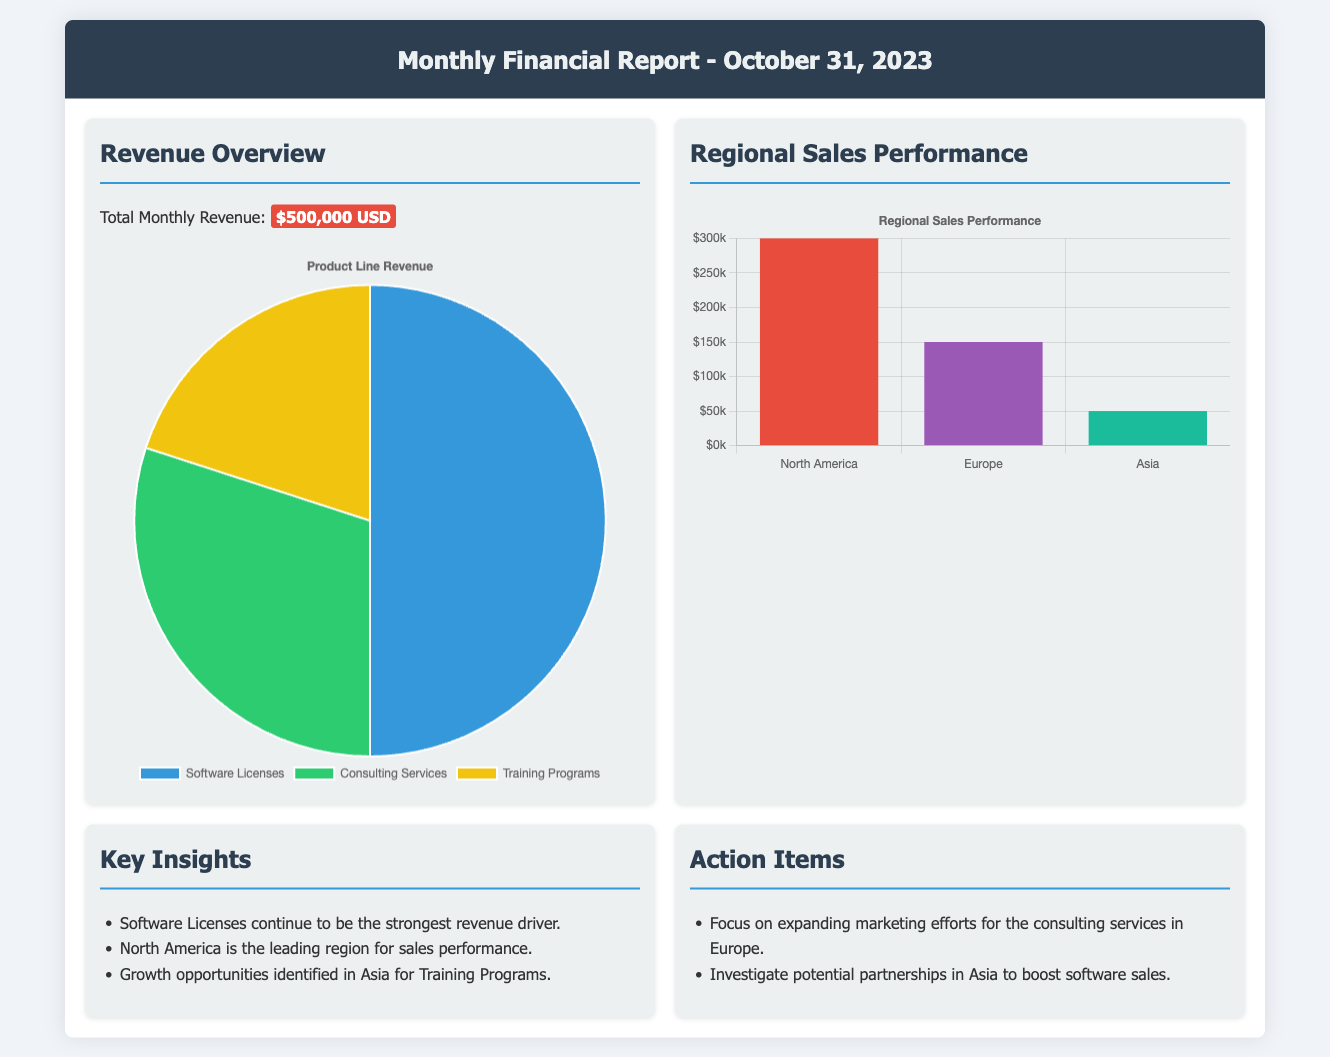What is the total monthly revenue? The total monthly revenue is clearly stated in the document under Revenue Overview, which amounts to $500,000 USD.
Answer: $500,000 USD Which product line is identified as the strongest revenue driver? The document lists the strongest revenue driver under Key Insights, which is Software Licenses.
Answer: Software Licenses What is the sales performance in North America? The sales performance in North America is detailed in the Regional Sales Performance section, with a revenue figure of $300,000.
Answer: $300,000 What growth opportunities have been identified? The document mentions growth opportunities under Key Insights, specifically in Asia for Training Programs.
Answer: Asia for Training Programs What is the revenue generated from Consulting Services? The revenue generated from Consulting Services is part of the pie chart data, which shows a figure of $150,000.
Answer: $150,000 What action item is suggested for European marketing efforts? The document suggests an action item focused on expanding marketing efforts for consulting services in Europe.
Answer: Expand marketing efforts for consulting services in Europe How much revenue is reported from Asia? The revenue from Asia is provided in the Regional Sales Performance section, which is noted as $50,000.
Answer: $50,000 What is the background color for the Software Licenses segment in the revenue chart? The background color for the Software Licenses segment in the pie chart is indicated in the code, which is #3498db.
Answer: #3498db 